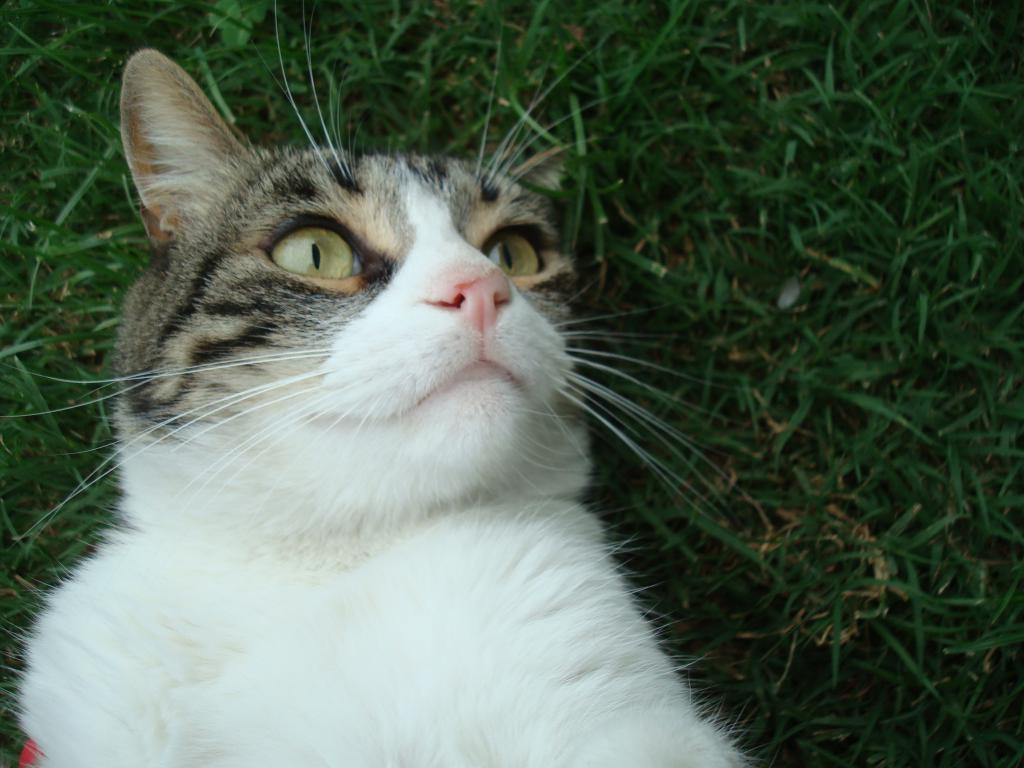How would you summarize this image in a sentence or two? In this picture we can see a cat on the grass. 